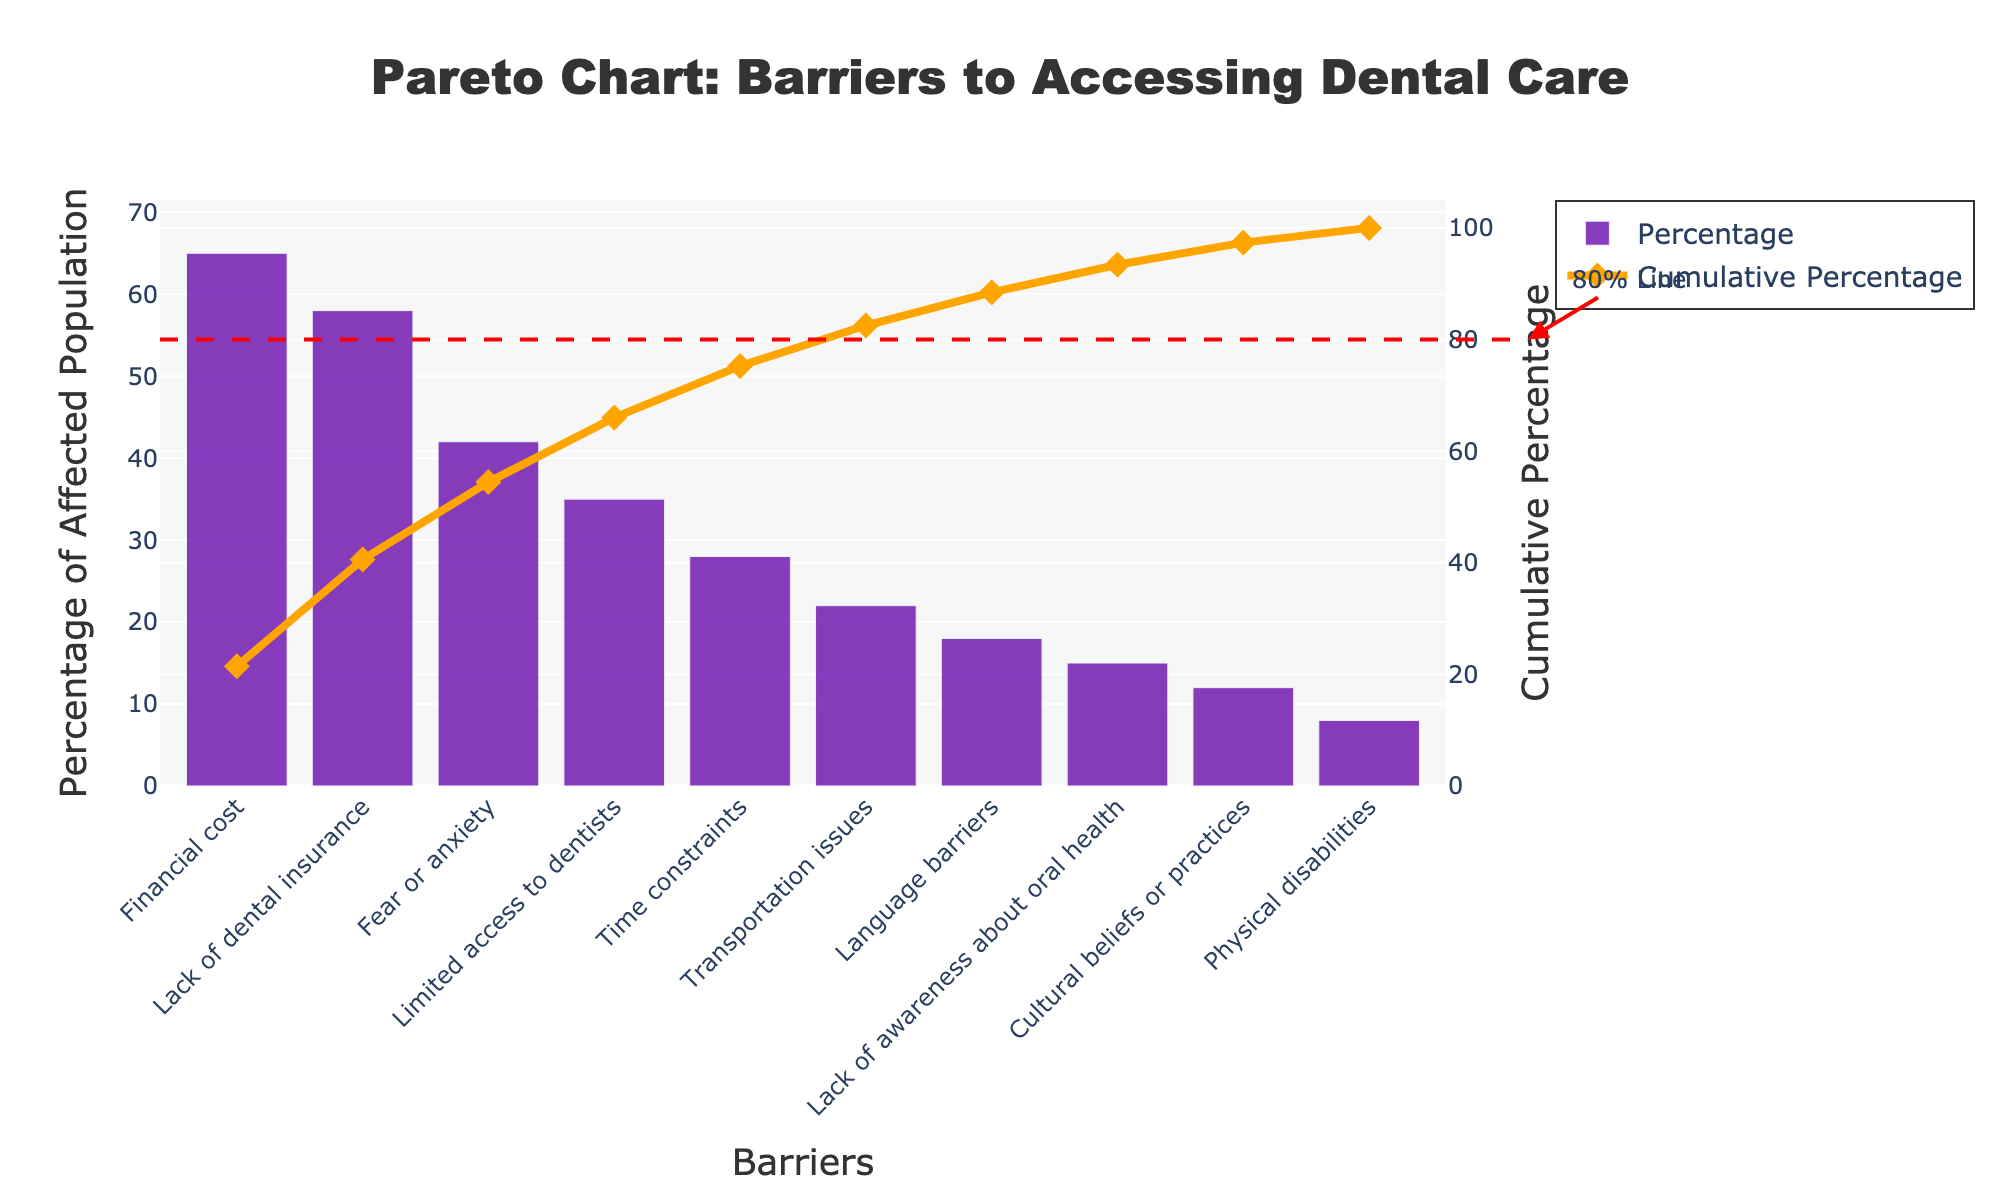What is the title of the chart? The title is placed at the top center of the chart and is in larger font. It reads: "Pareto Chart: Barriers to Accessing Dental Care"
Answer: Pareto Chart: Barriers to Accessing Dental Care How many barriers are listed in the chart? The chart lists the barriers along the x-axis, each represented by a bar. Counting these bars gives the total number of barriers.
Answer: 10 What color represents the percentage of the affected population in the chart? The bars that represent the percentage of the affected population are colored. This color is a shade of purple.
Answer: Purple Which barrier has the highest percentage of the affected population? The barrier with the highest bar represents the highest percentage. The topmost bar is labeled "Financial cost."
Answer: Financial cost What is the cumulative percentage for the barrier "Fear or anxiety"? The cumulative percentage line crosses each barrier point on the x-axis. Trace the line up to the barrier labeled "Fear or anxiety" to find the corresponding cumulative percentage on the right y-axis.
Answer: 89% What is the percentage difference between "Financial cost" and "Lack of dental insurance"? First, find the percentage values of both barriers, which are marked at the ends of the respective bars. Subtract the percentage of "Lack of dental insurance" (58%) from "Financial cost" (65%).
Answer: 7% How many barriers cover more than 80% of the cumulative percentage? The threshold line for 80% is drawn, identifiable by the annotation. Count the barriers intersected by the cumulative percentage line before it reaches this point.
Answer: 4 Which barriers fall below 20% in terms of the affected population? Check the bar lengths that are below the 20% mark on the left y-axis and note their corresponding labels.
Answer: Transportation issues, Language barriers, Lack of awareness about oral health, Cultural beliefs or practices, Physical disabilities What is the total percentage of the population affected by the top three barriers? Sum the percentages of the top three barriers: "Financial cost" (65%), "Lack of dental insurance" (58%), and "Fear or anxiety" (42%). 65 + 58 + 42 = 165
Answer: 165% If "Time constraints" were to increase by 10%, how would its rank change? First, identify the current percentage and rank of "Time constraints" (28%). Increasing by 10% means it would become 38%. Compare 38% with the other percentages (42%, 35%) to see where it would now fit; it would surpass "Limited access to dentists" but remain below "Fear or anxiety".
Answer: It would become 4th 